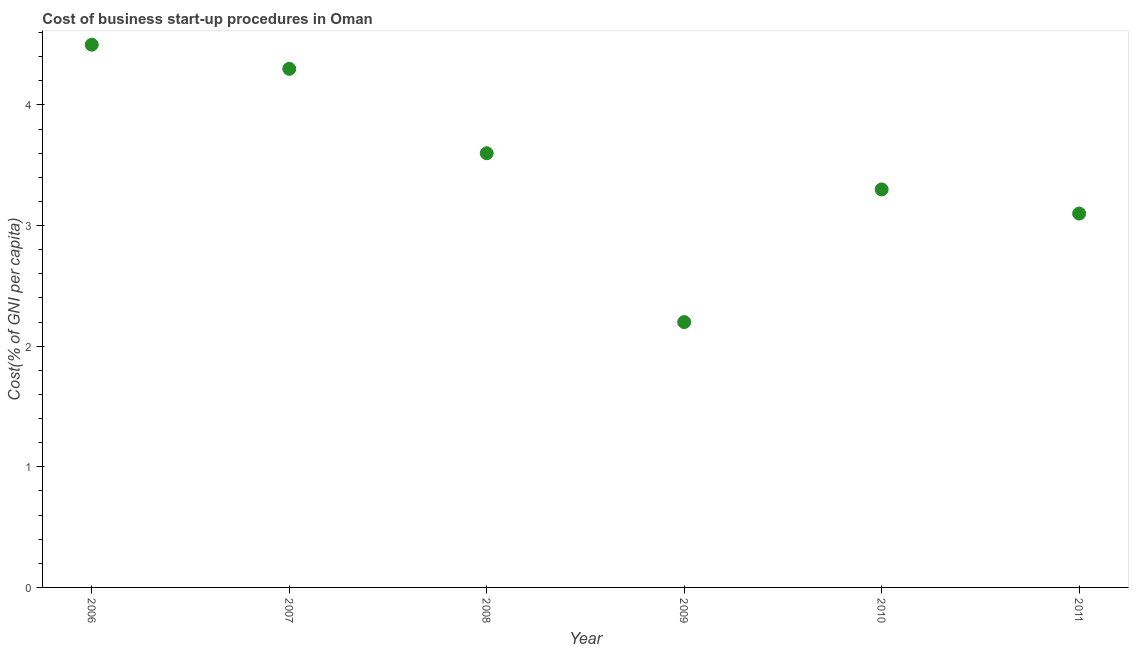Across all years, what is the maximum cost of business startup procedures?
Your response must be concise. 4.5. In which year was the cost of business startup procedures maximum?
Ensure brevity in your answer.  2006. What is the sum of the cost of business startup procedures?
Give a very brief answer. 21. What is the difference between the cost of business startup procedures in 2006 and 2007?
Provide a short and direct response. 0.2. What is the average cost of business startup procedures per year?
Make the answer very short. 3.5. What is the median cost of business startup procedures?
Ensure brevity in your answer.  3.45. Do a majority of the years between 2007 and 2010 (inclusive) have cost of business startup procedures greater than 2.8 %?
Your response must be concise. Yes. What is the ratio of the cost of business startup procedures in 2006 to that in 2008?
Ensure brevity in your answer.  1.25. Is the cost of business startup procedures in 2008 less than that in 2011?
Give a very brief answer. No. Is the difference between the cost of business startup procedures in 2008 and 2009 greater than the difference between any two years?
Your answer should be very brief. No. What is the difference between the highest and the second highest cost of business startup procedures?
Provide a succinct answer. 0.2. In how many years, is the cost of business startup procedures greater than the average cost of business startup procedures taken over all years?
Offer a terse response. 3. How many dotlines are there?
Offer a very short reply. 1. How many years are there in the graph?
Keep it short and to the point. 6. Are the values on the major ticks of Y-axis written in scientific E-notation?
Give a very brief answer. No. Does the graph contain grids?
Give a very brief answer. No. What is the title of the graph?
Make the answer very short. Cost of business start-up procedures in Oman. What is the label or title of the Y-axis?
Provide a short and direct response. Cost(% of GNI per capita). What is the Cost(% of GNI per capita) in 2009?
Provide a short and direct response. 2.2. What is the Cost(% of GNI per capita) in 2011?
Ensure brevity in your answer.  3.1. What is the difference between the Cost(% of GNI per capita) in 2006 and 2008?
Your answer should be very brief. 0.9. What is the difference between the Cost(% of GNI per capita) in 2006 and 2010?
Make the answer very short. 1.2. What is the difference between the Cost(% of GNI per capita) in 2007 and 2008?
Your response must be concise. 0.7. What is the difference between the Cost(% of GNI per capita) in 2007 and 2009?
Your answer should be very brief. 2.1. What is the difference between the Cost(% of GNI per capita) in 2007 and 2010?
Keep it short and to the point. 1. What is the difference between the Cost(% of GNI per capita) in 2007 and 2011?
Give a very brief answer. 1.2. What is the difference between the Cost(% of GNI per capita) in 2008 and 2010?
Your response must be concise. 0.3. What is the difference between the Cost(% of GNI per capita) in 2008 and 2011?
Give a very brief answer. 0.5. What is the difference between the Cost(% of GNI per capita) in 2010 and 2011?
Offer a very short reply. 0.2. What is the ratio of the Cost(% of GNI per capita) in 2006 to that in 2007?
Offer a terse response. 1.05. What is the ratio of the Cost(% of GNI per capita) in 2006 to that in 2008?
Provide a succinct answer. 1.25. What is the ratio of the Cost(% of GNI per capita) in 2006 to that in 2009?
Ensure brevity in your answer.  2.04. What is the ratio of the Cost(% of GNI per capita) in 2006 to that in 2010?
Provide a succinct answer. 1.36. What is the ratio of the Cost(% of GNI per capita) in 2006 to that in 2011?
Your answer should be very brief. 1.45. What is the ratio of the Cost(% of GNI per capita) in 2007 to that in 2008?
Give a very brief answer. 1.19. What is the ratio of the Cost(% of GNI per capita) in 2007 to that in 2009?
Ensure brevity in your answer.  1.96. What is the ratio of the Cost(% of GNI per capita) in 2007 to that in 2010?
Your response must be concise. 1.3. What is the ratio of the Cost(% of GNI per capita) in 2007 to that in 2011?
Offer a very short reply. 1.39. What is the ratio of the Cost(% of GNI per capita) in 2008 to that in 2009?
Your answer should be compact. 1.64. What is the ratio of the Cost(% of GNI per capita) in 2008 to that in 2010?
Your response must be concise. 1.09. What is the ratio of the Cost(% of GNI per capita) in 2008 to that in 2011?
Provide a short and direct response. 1.16. What is the ratio of the Cost(% of GNI per capita) in 2009 to that in 2010?
Your answer should be compact. 0.67. What is the ratio of the Cost(% of GNI per capita) in 2009 to that in 2011?
Provide a succinct answer. 0.71. What is the ratio of the Cost(% of GNI per capita) in 2010 to that in 2011?
Provide a short and direct response. 1.06. 